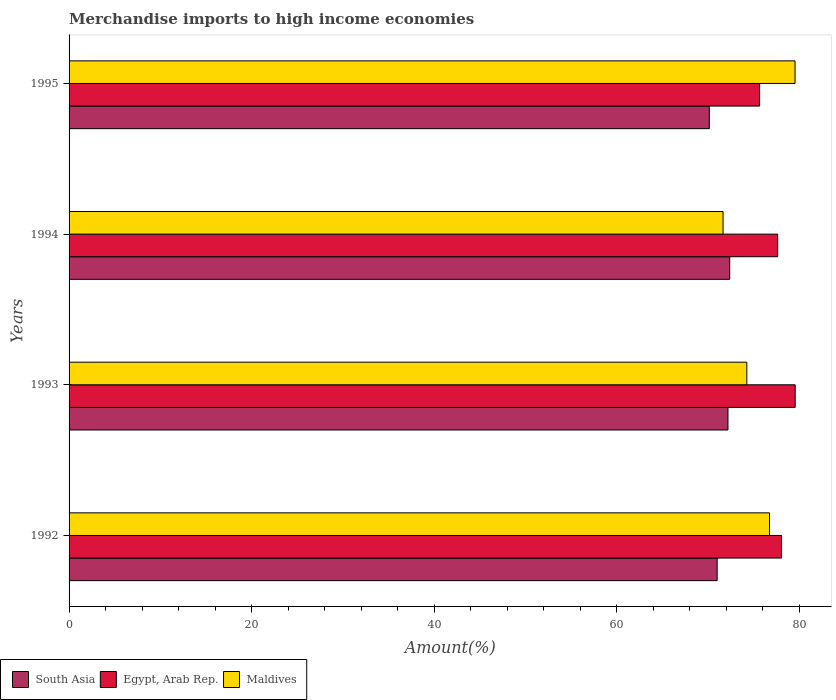How many bars are there on the 1st tick from the top?
Offer a very short reply. 3. What is the label of the 2nd group of bars from the top?
Your answer should be compact. 1994. What is the percentage of amount earned from merchandise imports in Egypt, Arab Rep. in 1994?
Provide a succinct answer. 77.66. Across all years, what is the maximum percentage of amount earned from merchandise imports in Maldives?
Offer a terse response. 79.56. Across all years, what is the minimum percentage of amount earned from merchandise imports in Maldives?
Provide a short and direct response. 71.67. In which year was the percentage of amount earned from merchandise imports in Egypt, Arab Rep. maximum?
Your response must be concise. 1993. In which year was the percentage of amount earned from merchandise imports in Egypt, Arab Rep. minimum?
Offer a very short reply. 1995. What is the total percentage of amount earned from merchandise imports in Egypt, Arab Rep. in the graph?
Make the answer very short. 310.99. What is the difference between the percentage of amount earned from merchandise imports in Egypt, Arab Rep. in 1994 and that in 1995?
Your response must be concise. 1.98. What is the difference between the percentage of amount earned from merchandise imports in Maldives in 1992 and the percentage of amount earned from merchandise imports in South Asia in 1995?
Ensure brevity in your answer.  6.6. What is the average percentage of amount earned from merchandise imports in Maldives per year?
Offer a terse response. 75.57. In the year 1994, what is the difference between the percentage of amount earned from merchandise imports in South Asia and percentage of amount earned from merchandise imports in Maldives?
Provide a succinct answer. 0.73. In how many years, is the percentage of amount earned from merchandise imports in Maldives greater than 20 %?
Your answer should be compact. 4. What is the ratio of the percentage of amount earned from merchandise imports in South Asia in 1993 to that in 1994?
Keep it short and to the point. 1. Is the difference between the percentage of amount earned from merchandise imports in South Asia in 1992 and 1993 greater than the difference between the percentage of amount earned from merchandise imports in Maldives in 1992 and 1993?
Offer a very short reply. No. What is the difference between the highest and the second highest percentage of amount earned from merchandise imports in Maldives?
Give a very brief answer. 2.8. What is the difference between the highest and the lowest percentage of amount earned from merchandise imports in Egypt, Arab Rep.?
Provide a succinct answer. 3.9. What does the 3rd bar from the bottom in 1992 represents?
Make the answer very short. Maldives. How many bars are there?
Provide a short and direct response. 12. Are all the bars in the graph horizontal?
Your response must be concise. Yes. What is the difference between two consecutive major ticks on the X-axis?
Your answer should be compact. 20. Does the graph contain any zero values?
Offer a very short reply. No. Does the graph contain grids?
Your answer should be very brief. No. How many legend labels are there?
Provide a succinct answer. 3. How are the legend labels stacked?
Keep it short and to the point. Horizontal. What is the title of the graph?
Give a very brief answer. Merchandise imports to high income economies. Does "Curacao" appear as one of the legend labels in the graph?
Give a very brief answer. No. What is the label or title of the X-axis?
Keep it short and to the point. Amount(%). What is the Amount(%) in South Asia in 1992?
Give a very brief answer. 71.03. What is the Amount(%) in Egypt, Arab Rep. in 1992?
Provide a short and direct response. 78.08. What is the Amount(%) in Maldives in 1992?
Your response must be concise. 76.76. What is the Amount(%) in South Asia in 1993?
Provide a short and direct response. 72.21. What is the Amount(%) of Egypt, Arab Rep. in 1993?
Give a very brief answer. 79.58. What is the Amount(%) in Maldives in 1993?
Offer a very short reply. 74.27. What is the Amount(%) in South Asia in 1994?
Give a very brief answer. 72.4. What is the Amount(%) of Egypt, Arab Rep. in 1994?
Offer a terse response. 77.66. What is the Amount(%) in Maldives in 1994?
Make the answer very short. 71.67. What is the Amount(%) in South Asia in 1995?
Provide a succinct answer. 70.17. What is the Amount(%) in Egypt, Arab Rep. in 1995?
Your answer should be compact. 75.67. What is the Amount(%) in Maldives in 1995?
Your response must be concise. 79.56. Across all years, what is the maximum Amount(%) in South Asia?
Your answer should be compact. 72.4. Across all years, what is the maximum Amount(%) in Egypt, Arab Rep.?
Provide a succinct answer. 79.58. Across all years, what is the maximum Amount(%) in Maldives?
Your response must be concise. 79.56. Across all years, what is the minimum Amount(%) of South Asia?
Offer a very short reply. 70.17. Across all years, what is the minimum Amount(%) in Egypt, Arab Rep.?
Keep it short and to the point. 75.67. Across all years, what is the minimum Amount(%) of Maldives?
Make the answer very short. 71.67. What is the total Amount(%) in South Asia in the graph?
Your response must be concise. 285.8. What is the total Amount(%) in Egypt, Arab Rep. in the graph?
Your answer should be very brief. 310.99. What is the total Amount(%) of Maldives in the graph?
Your answer should be very brief. 302.27. What is the difference between the Amount(%) of South Asia in 1992 and that in 1993?
Your answer should be very brief. -1.18. What is the difference between the Amount(%) in Egypt, Arab Rep. in 1992 and that in 1993?
Ensure brevity in your answer.  -1.49. What is the difference between the Amount(%) in Maldives in 1992 and that in 1993?
Ensure brevity in your answer.  2.49. What is the difference between the Amount(%) in South Asia in 1992 and that in 1994?
Keep it short and to the point. -1.37. What is the difference between the Amount(%) in Egypt, Arab Rep. in 1992 and that in 1994?
Ensure brevity in your answer.  0.43. What is the difference between the Amount(%) of Maldives in 1992 and that in 1994?
Your answer should be very brief. 5.09. What is the difference between the Amount(%) of South Asia in 1992 and that in 1995?
Offer a terse response. 0.86. What is the difference between the Amount(%) in Egypt, Arab Rep. in 1992 and that in 1995?
Provide a succinct answer. 2.41. What is the difference between the Amount(%) of Maldives in 1992 and that in 1995?
Your response must be concise. -2.8. What is the difference between the Amount(%) in South Asia in 1993 and that in 1994?
Provide a short and direct response. -0.19. What is the difference between the Amount(%) in Egypt, Arab Rep. in 1993 and that in 1994?
Provide a succinct answer. 1.92. What is the difference between the Amount(%) in Maldives in 1993 and that in 1994?
Offer a terse response. 2.6. What is the difference between the Amount(%) of South Asia in 1993 and that in 1995?
Offer a terse response. 2.04. What is the difference between the Amount(%) in Egypt, Arab Rep. in 1993 and that in 1995?
Keep it short and to the point. 3.9. What is the difference between the Amount(%) in Maldives in 1993 and that in 1995?
Provide a succinct answer. -5.29. What is the difference between the Amount(%) in South Asia in 1994 and that in 1995?
Give a very brief answer. 2.23. What is the difference between the Amount(%) in Egypt, Arab Rep. in 1994 and that in 1995?
Provide a succinct answer. 1.98. What is the difference between the Amount(%) of Maldives in 1994 and that in 1995?
Ensure brevity in your answer.  -7.89. What is the difference between the Amount(%) of South Asia in 1992 and the Amount(%) of Egypt, Arab Rep. in 1993?
Your answer should be very brief. -8.55. What is the difference between the Amount(%) in South Asia in 1992 and the Amount(%) in Maldives in 1993?
Provide a succinct answer. -3.25. What is the difference between the Amount(%) of Egypt, Arab Rep. in 1992 and the Amount(%) of Maldives in 1993?
Your response must be concise. 3.81. What is the difference between the Amount(%) in South Asia in 1992 and the Amount(%) in Egypt, Arab Rep. in 1994?
Offer a very short reply. -6.63. What is the difference between the Amount(%) of South Asia in 1992 and the Amount(%) of Maldives in 1994?
Offer a terse response. -0.64. What is the difference between the Amount(%) in Egypt, Arab Rep. in 1992 and the Amount(%) in Maldives in 1994?
Your answer should be compact. 6.41. What is the difference between the Amount(%) of South Asia in 1992 and the Amount(%) of Egypt, Arab Rep. in 1995?
Your response must be concise. -4.65. What is the difference between the Amount(%) of South Asia in 1992 and the Amount(%) of Maldives in 1995?
Your answer should be compact. -8.53. What is the difference between the Amount(%) in Egypt, Arab Rep. in 1992 and the Amount(%) in Maldives in 1995?
Provide a succinct answer. -1.48. What is the difference between the Amount(%) of South Asia in 1993 and the Amount(%) of Egypt, Arab Rep. in 1994?
Give a very brief answer. -5.45. What is the difference between the Amount(%) in South Asia in 1993 and the Amount(%) in Maldives in 1994?
Your answer should be compact. 0.54. What is the difference between the Amount(%) of Egypt, Arab Rep. in 1993 and the Amount(%) of Maldives in 1994?
Ensure brevity in your answer.  7.9. What is the difference between the Amount(%) of South Asia in 1993 and the Amount(%) of Egypt, Arab Rep. in 1995?
Ensure brevity in your answer.  -3.47. What is the difference between the Amount(%) of South Asia in 1993 and the Amount(%) of Maldives in 1995?
Your answer should be compact. -7.35. What is the difference between the Amount(%) of Egypt, Arab Rep. in 1993 and the Amount(%) of Maldives in 1995?
Your answer should be very brief. 0.01. What is the difference between the Amount(%) in South Asia in 1994 and the Amount(%) in Egypt, Arab Rep. in 1995?
Your response must be concise. -3.27. What is the difference between the Amount(%) in South Asia in 1994 and the Amount(%) in Maldives in 1995?
Give a very brief answer. -7.16. What is the difference between the Amount(%) of Egypt, Arab Rep. in 1994 and the Amount(%) of Maldives in 1995?
Ensure brevity in your answer.  -1.91. What is the average Amount(%) of South Asia per year?
Your response must be concise. 71.45. What is the average Amount(%) of Egypt, Arab Rep. per year?
Keep it short and to the point. 77.75. What is the average Amount(%) in Maldives per year?
Keep it short and to the point. 75.57. In the year 1992, what is the difference between the Amount(%) in South Asia and Amount(%) in Egypt, Arab Rep.?
Your response must be concise. -7.06. In the year 1992, what is the difference between the Amount(%) in South Asia and Amount(%) in Maldives?
Offer a very short reply. -5.74. In the year 1992, what is the difference between the Amount(%) of Egypt, Arab Rep. and Amount(%) of Maldives?
Offer a terse response. 1.32. In the year 1993, what is the difference between the Amount(%) in South Asia and Amount(%) in Egypt, Arab Rep.?
Ensure brevity in your answer.  -7.37. In the year 1993, what is the difference between the Amount(%) of South Asia and Amount(%) of Maldives?
Your response must be concise. -2.06. In the year 1993, what is the difference between the Amount(%) in Egypt, Arab Rep. and Amount(%) in Maldives?
Give a very brief answer. 5.3. In the year 1994, what is the difference between the Amount(%) in South Asia and Amount(%) in Egypt, Arab Rep.?
Offer a very short reply. -5.25. In the year 1994, what is the difference between the Amount(%) of South Asia and Amount(%) of Maldives?
Keep it short and to the point. 0.73. In the year 1994, what is the difference between the Amount(%) in Egypt, Arab Rep. and Amount(%) in Maldives?
Ensure brevity in your answer.  5.98. In the year 1995, what is the difference between the Amount(%) in South Asia and Amount(%) in Egypt, Arab Rep.?
Ensure brevity in your answer.  -5.51. In the year 1995, what is the difference between the Amount(%) of South Asia and Amount(%) of Maldives?
Provide a succinct answer. -9.39. In the year 1995, what is the difference between the Amount(%) in Egypt, Arab Rep. and Amount(%) in Maldives?
Offer a very short reply. -3.89. What is the ratio of the Amount(%) of South Asia in 1992 to that in 1993?
Give a very brief answer. 0.98. What is the ratio of the Amount(%) of Egypt, Arab Rep. in 1992 to that in 1993?
Your answer should be very brief. 0.98. What is the ratio of the Amount(%) in Maldives in 1992 to that in 1993?
Give a very brief answer. 1.03. What is the ratio of the Amount(%) in South Asia in 1992 to that in 1994?
Ensure brevity in your answer.  0.98. What is the ratio of the Amount(%) of Egypt, Arab Rep. in 1992 to that in 1994?
Your answer should be compact. 1.01. What is the ratio of the Amount(%) in Maldives in 1992 to that in 1994?
Offer a terse response. 1.07. What is the ratio of the Amount(%) in South Asia in 1992 to that in 1995?
Your response must be concise. 1.01. What is the ratio of the Amount(%) of Egypt, Arab Rep. in 1992 to that in 1995?
Your response must be concise. 1.03. What is the ratio of the Amount(%) of Maldives in 1992 to that in 1995?
Give a very brief answer. 0.96. What is the ratio of the Amount(%) in Egypt, Arab Rep. in 1993 to that in 1994?
Offer a terse response. 1.02. What is the ratio of the Amount(%) of Maldives in 1993 to that in 1994?
Make the answer very short. 1.04. What is the ratio of the Amount(%) of South Asia in 1993 to that in 1995?
Provide a succinct answer. 1.03. What is the ratio of the Amount(%) in Egypt, Arab Rep. in 1993 to that in 1995?
Ensure brevity in your answer.  1.05. What is the ratio of the Amount(%) of Maldives in 1993 to that in 1995?
Your answer should be compact. 0.93. What is the ratio of the Amount(%) in South Asia in 1994 to that in 1995?
Your response must be concise. 1.03. What is the ratio of the Amount(%) in Egypt, Arab Rep. in 1994 to that in 1995?
Offer a very short reply. 1.03. What is the ratio of the Amount(%) in Maldives in 1994 to that in 1995?
Provide a succinct answer. 0.9. What is the difference between the highest and the second highest Amount(%) in South Asia?
Provide a short and direct response. 0.19. What is the difference between the highest and the second highest Amount(%) in Egypt, Arab Rep.?
Your answer should be very brief. 1.49. What is the difference between the highest and the second highest Amount(%) of Maldives?
Give a very brief answer. 2.8. What is the difference between the highest and the lowest Amount(%) in South Asia?
Your answer should be compact. 2.23. What is the difference between the highest and the lowest Amount(%) in Egypt, Arab Rep.?
Your answer should be very brief. 3.9. What is the difference between the highest and the lowest Amount(%) in Maldives?
Your answer should be compact. 7.89. 